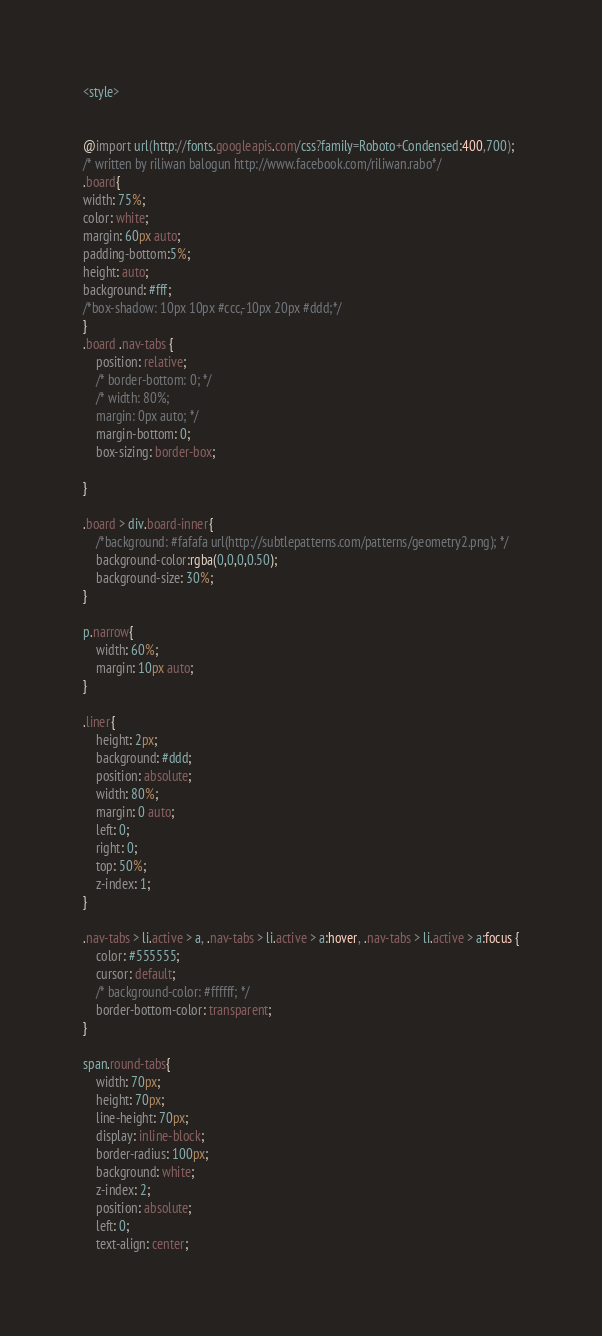Convert code to text. <code><loc_0><loc_0><loc_500><loc_500><_CSS_><style>


@import url(http://fonts.googleapis.com/css?family=Roboto+Condensed:400,700);
/* written by riliwan balogun http://www.facebook.com/riliwan.rabo*/
.board{
width: 75%;
color: white;
margin: 60px auto;
padding-bottom:5%;
height: auto;
background: #fff;
/*box-shadow: 10px 10px #ccc,-10px 20px #ddd;*/
}
.board .nav-tabs {
    position: relative;
    /* border-bottom: 0; */
    /* width: 80%; 
    margin: 0px auto; */
    margin-bottom: 0;
    box-sizing: border-box;

}

.board > div.board-inner{
    /*background: #fafafa url(http://subtlepatterns.com/patterns/geometry2.png); */
	background-color:rgba(0,0,0,0.50);
    background-size: 30%;
}

p.narrow{
    width: 60%;
    margin: 10px auto;
}

.liner{
    height: 2px;
    background: #ddd;
    position: absolute;
    width: 80%;
    margin: 0 auto;
    left: 0;
    right: 0;
    top: 50%;
    z-index: 1;
}

.nav-tabs > li.active > a, .nav-tabs > li.active > a:hover, .nav-tabs > li.active > a:focus {
    color: #555555;
    cursor: default;
    /* background-color: #ffffff; */
    border-bottom-color: transparent;
}

span.round-tabs{
    width: 70px;
    height: 70px;
    line-height: 70px;
    display: inline-block;
    border-radius: 100px;
    background: white;
    z-index: 2;
    position: absolute;
    left: 0;
    text-align: center;</code> 